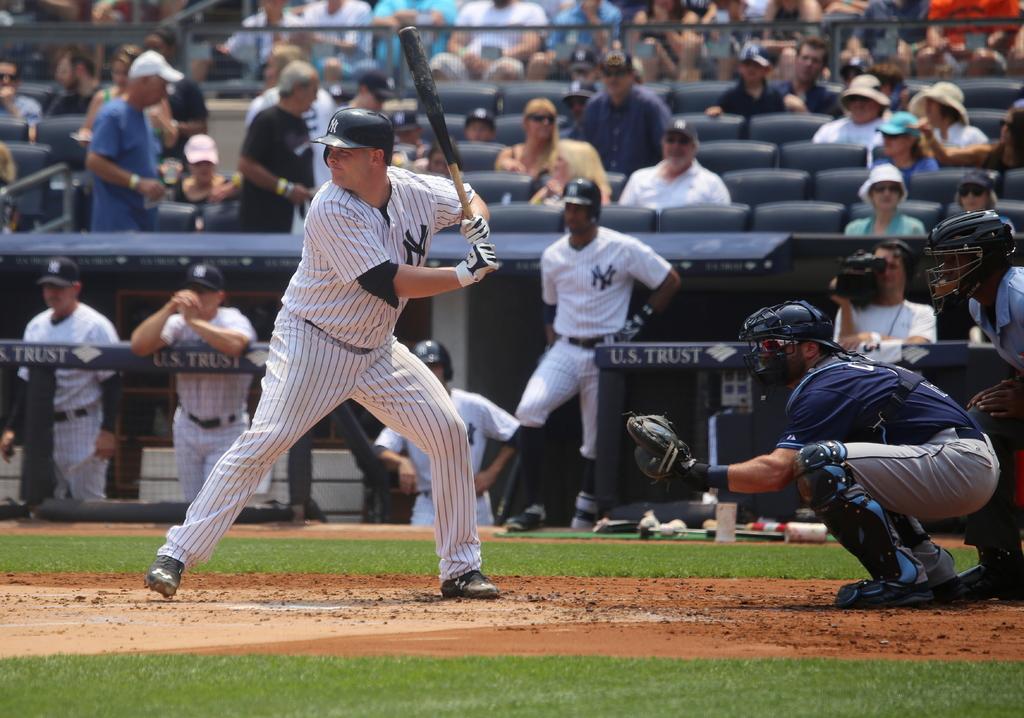What letters are on the players chest?
Provide a short and direct response. Ny. What country is mentioned next to the word trust on the fence?
Give a very brief answer. U.s. 